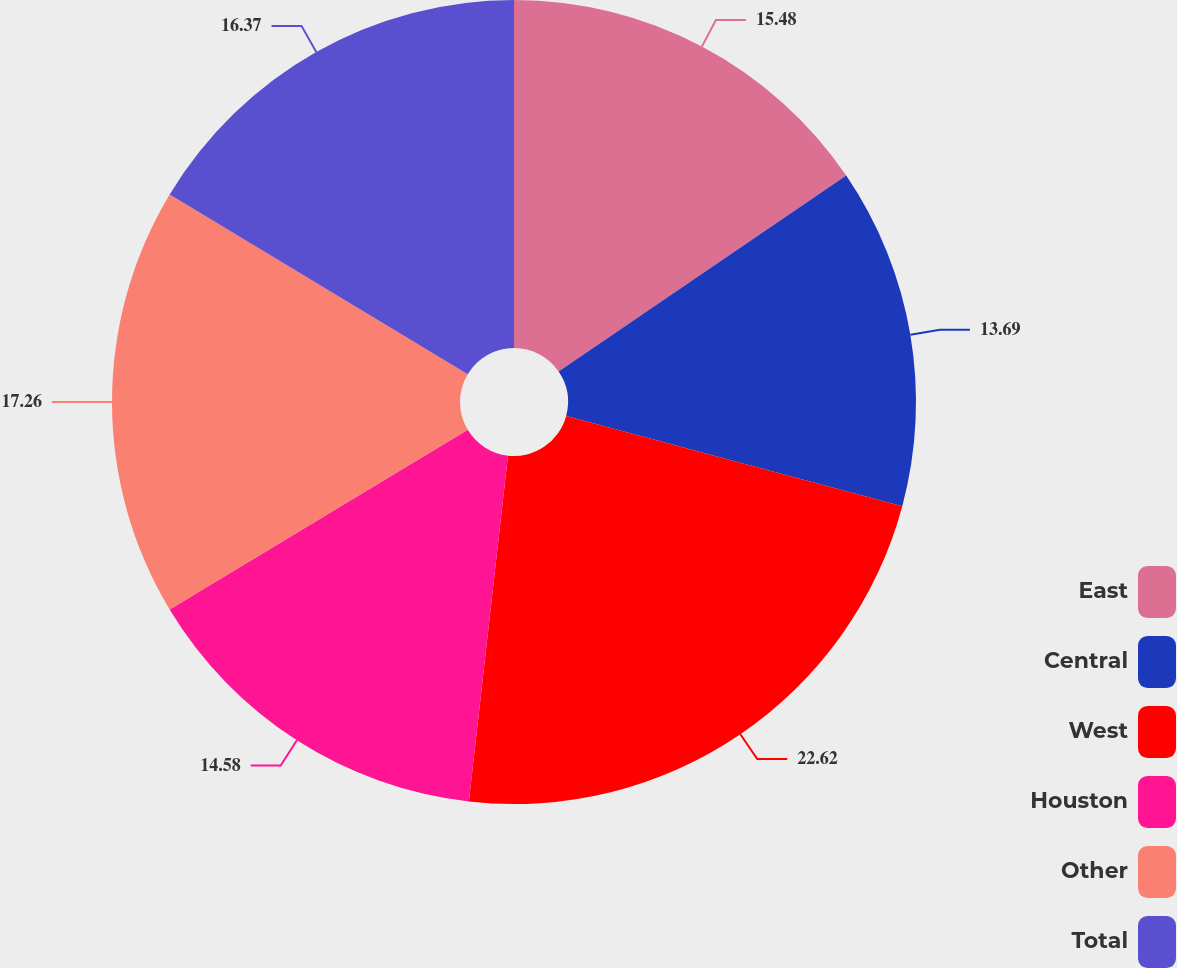Convert chart. <chart><loc_0><loc_0><loc_500><loc_500><pie_chart><fcel>East<fcel>Central<fcel>West<fcel>Houston<fcel>Other<fcel>Total<nl><fcel>15.48%<fcel>13.69%<fcel>22.62%<fcel>14.58%<fcel>17.26%<fcel>16.37%<nl></chart> 